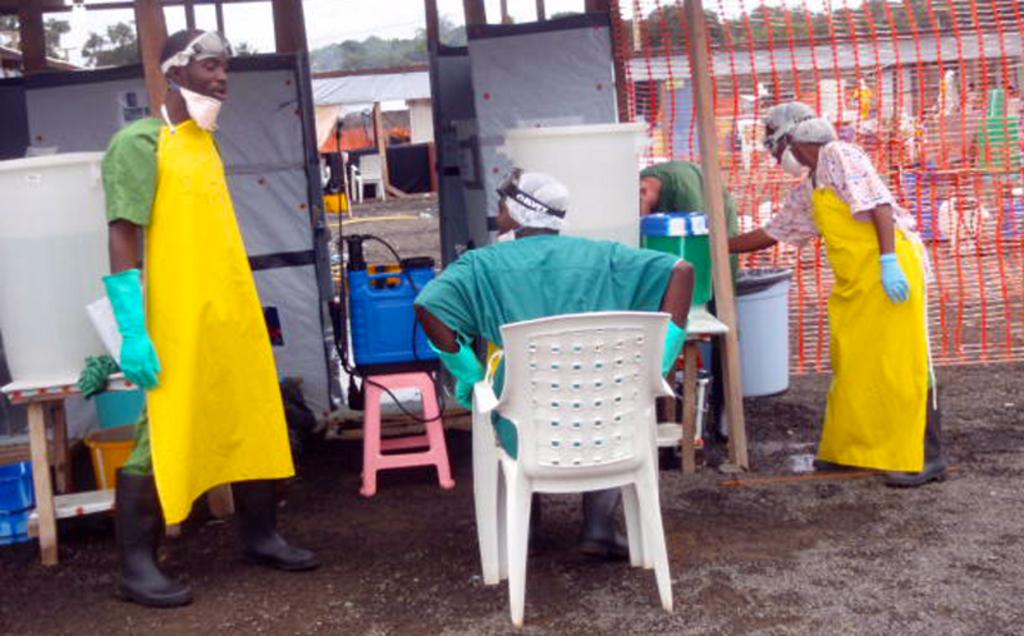How many people are in the image? There are three people in the image: a man standing on the left side, a man sitting in the middle, and a woman standing on the right side. What are the positions of the people in the image? One man is standing on the left side, another man is sitting in the middle, and a woman is standing on the right side. What can be inferred about the setting of the image? The setting appears to be an old station. Are there any grapes visible in the image? There are no grapes present in the image. Is there any quicksand in the image? There is no quicksand present in the image. 